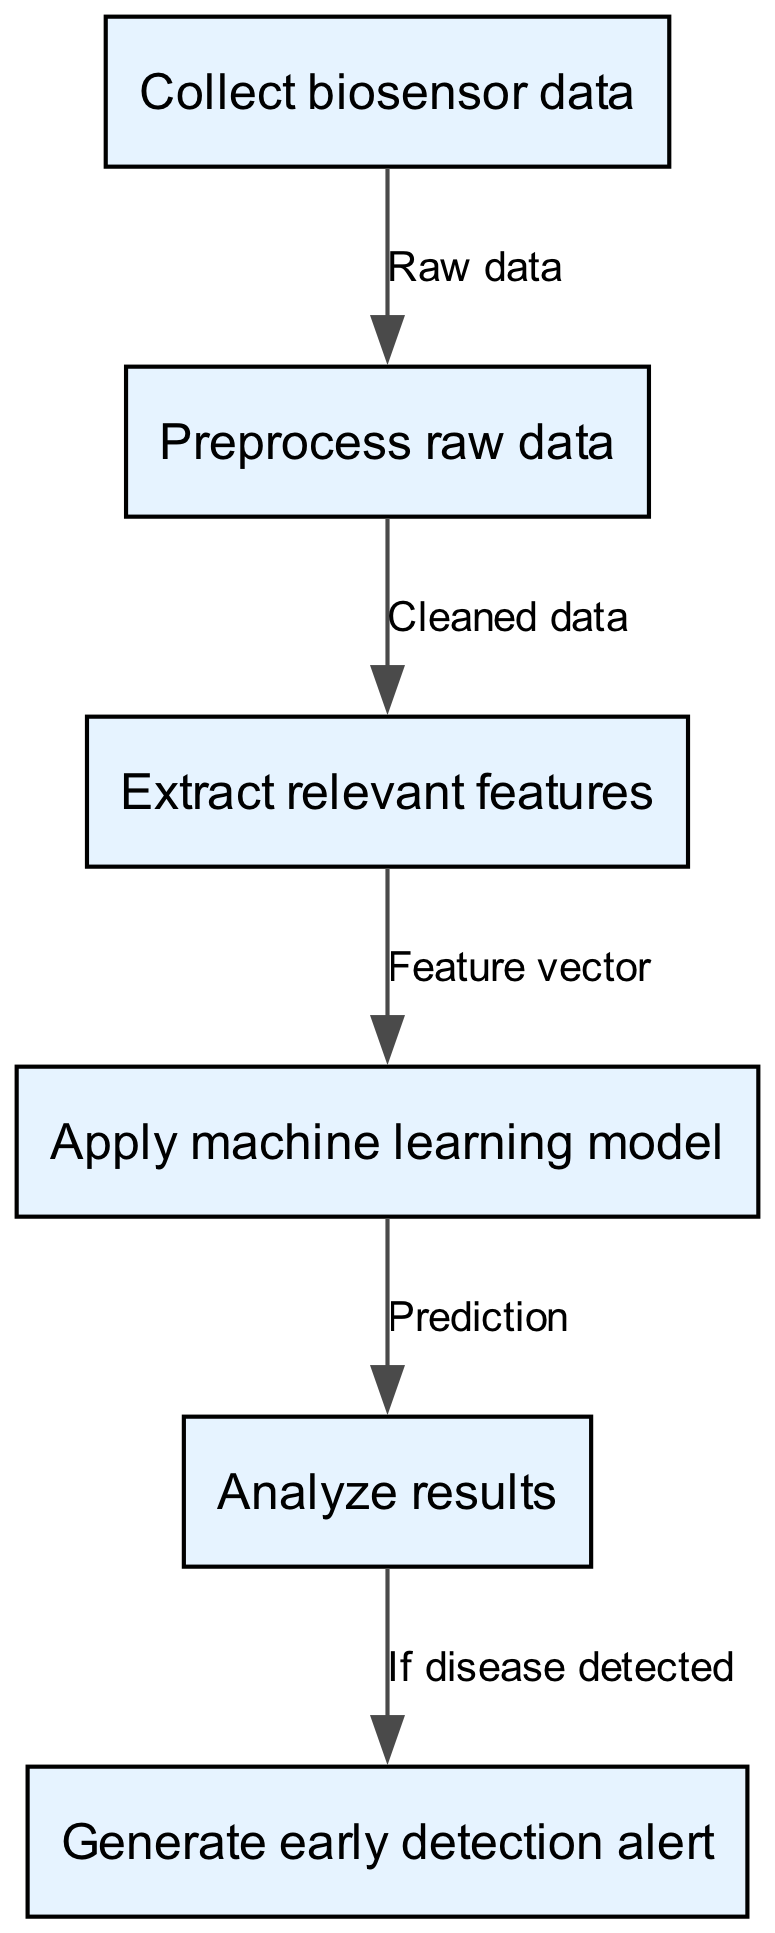What is the first step in the process? The first step in the flowchart is indicated by the first node, which specifically states "Collect biosensor data." Thus, this is the action that initiates the entire process.
Answer: Collect biosensor data How many nodes are there in total? By counting the nodes listed in the diagram, we find a total of six distinct nodes: Collect biosensor data, Preprocess raw data, Extract relevant features, Apply machine learning model, Analyze results, and Generate early detection alert.
Answer: 6 What type of data outputs from the "Preprocess raw data" step? In analyzing the edges in the diagram, the edge originating from the "Preprocess raw data" node leads to "Extract relevant features" and is labeled as "Cleaned data." This indicates that the output is cleaned data, resulting from preprocessing the raw data.
Answer: Cleaned data What action is performed after "Apply machine learning model"? The subsequent step following "Apply machine learning model" is "Analyze results," according to the flow of the edges in the diagram. These nodes are connected directly showing the sequential process after applying the model.
Answer: Analyze results If disease is detected in the analysis, what alert is generated? Referring to the final two nodes in the diagram where the edge from "Analyze results" to "Generate early detection alert" is labeled "If disease detected," it clearly indicates what alert is generated, which is an early detection alert.
Answer: Early detection alert What is the relationship between "Extract relevant features" and "Apply machine learning model"? The flowchart shows a direct connection (edge) from "Extract relevant features" to "Apply machine learning model." This implies that the extracted features serve as input (feature vector) for the machine learning model to make predictions.
Answer: Feature vector 